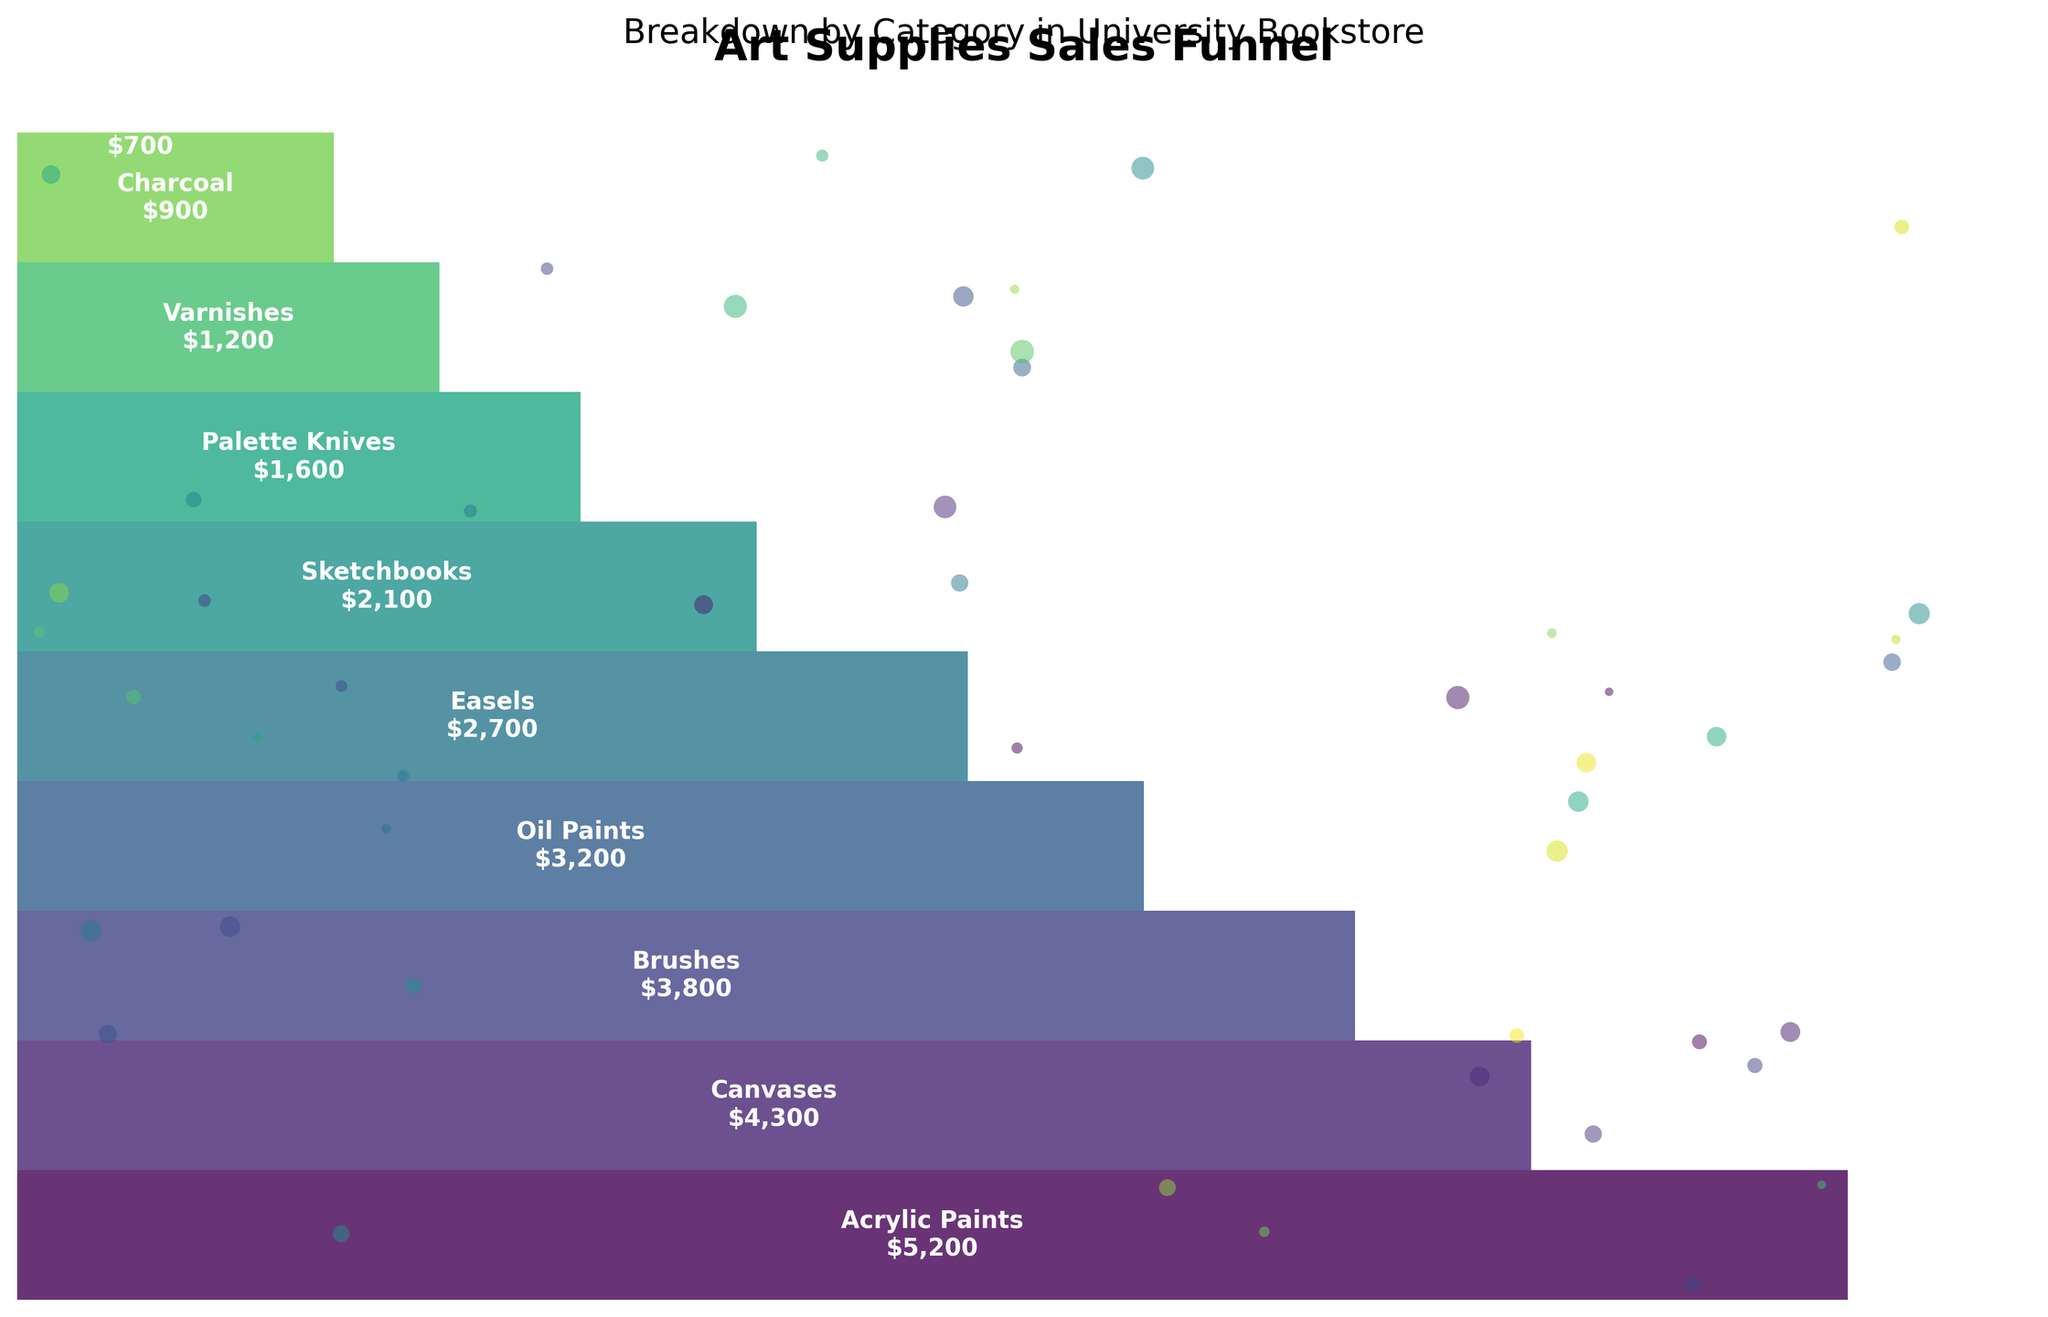What is the title of the funnel chart? The title is typically located at the top of the chart and describes what the chart is about. In this case, you can see the title "Art Supplies Sales Funnel" with a subtitle "Breakdown by Category in University Bookstore".
Answer: Art Supplies Sales Funnel Which art supply category has the highest sales? The category with the largest segment at the top of the funnel chart represents the highest sales. In this case, it is clearly labeled at the top with "Acrylic Paints" and a sales value of $5,200.
Answer: Acrylic Paints How many categories are represented in the funnel chart? To determine this, you can count the distinct segments in the funnel chart. Each segment represents a different category of art supplies. By counting from the top to the bottom, you can see there are 10 segments.
Answer: 10 What is the total sales value of Canvases and Brushes? First, locate the segments for Canvases and Brushes. Canvases have a sales value of $4,300, and Brushes have a sales value of $3,800. Adding these two values together gives $4,300 + $3,800.
Answer: $8,100 Which category has lower sales: Easels or Oil Paints? To compare these two categories, look at their segments. Easels have a sales value of $2,700, and Oil Paints have a sales value of $3,200. Easels have the lower sales value.
Answer: Easels What is the average sales value of the bottom three categories? The bottom three categories are Charcoal, Pastels, and Varnishes with sales values of $900, $700, and $1,200, respectively. The average sales value is calculated as follows: ($900 + $700 + $1,200) / 3 = $2,800 / 3.
Answer: $933.33 Which categories contribute to over 50% of the total sales? To determine this, identify the cumulative sales that exceed 50% of the total. Acrylic Paints ($5,200), Canvases ($4,300), and Brushes ($3,800) combined are $13,300, which is more than 50% of the total sales. These sales figures add up to 65% of the total sales.
Answer: Acrylic Paints, Canvases, Brushes What is the difference in sales between the category with the highest sales and the category with the lowest sales? The highest sales are for Acrylic Paints ($5,200) and the lowest for Pastels ($700). The difference is calculated as $5,200 - $700.
Answer: $4,500 What percentage of the total sales are contributed by Sketchbooks? Find the sales value for Sketchbooks ($2,100) and divide it by the total sales value to get the percentage. The total sales are $26,700, so the percentage is calculated as ($2,100 / $26,700) * 100.
Answer: 7.87% How does the sales value of Oil Paints compare to that of Charcoal? Locate the sales values for both categories. Oil Paints have a sales value of $3,200 and Charcoal has a sales value of $900. Oil Paints have higher sales.
Answer: Oil Paints have higher sales 